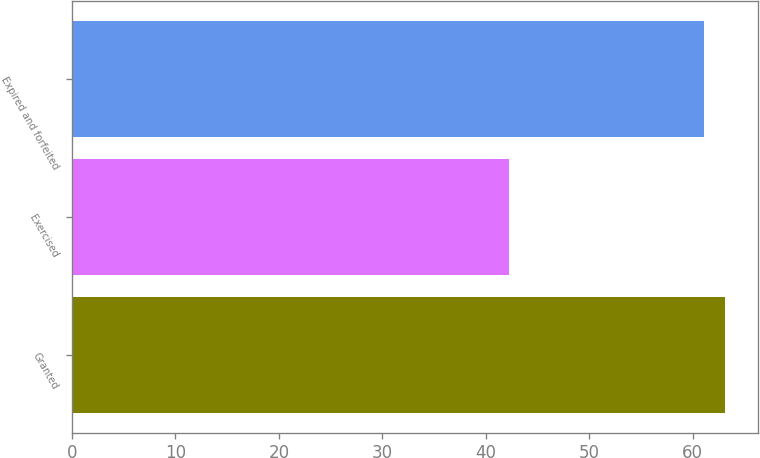<chart> <loc_0><loc_0><loc_500><loc_500><bar_chart><fcel>Granted<fcel>Exercised<fcel>Expired and forfeited<nl><fcel>63.14<fcel>42.27<fcel>61.12<nl></chart> 